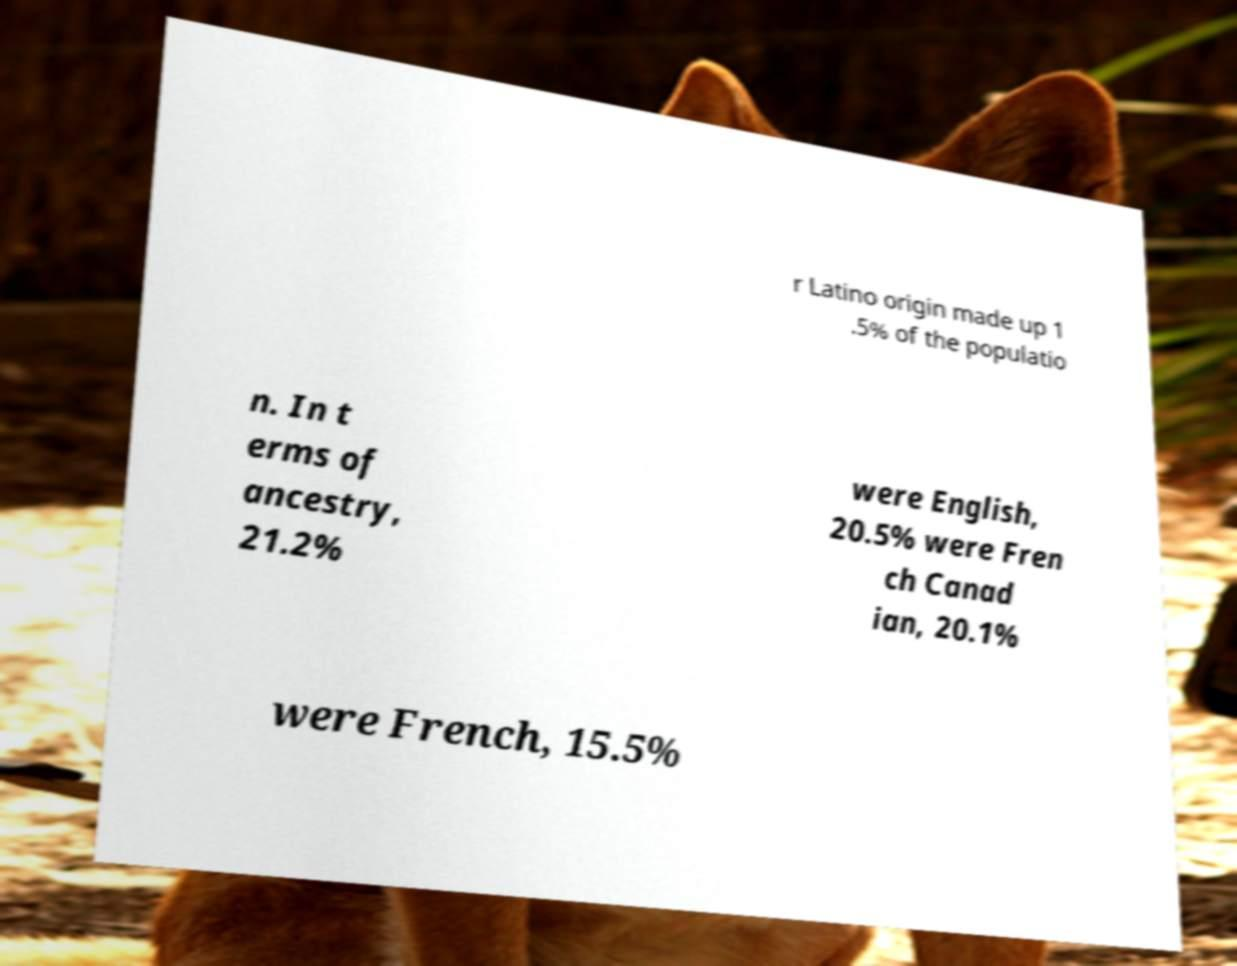What messages or text are displayed in this image? I need them in a readable, typed format. r Latino origin made up 1 .5% of the populatio n. In t erms of ancestry, 21.2% were English, 20.5% were Fren ch Canad ian, 20.1% were French, 15.5% 